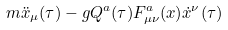Convert formula to latex. <formula><loc_0><loc_0><loc_500><loc_500>m \ddot { x } _ { \mu } ( \tau ) - g Q ^ { a } ( \tau ) F ^ { a } _ { \mu \nu } ( x ) \dot { x } ^ { \nu } ( \tau )</formula> 